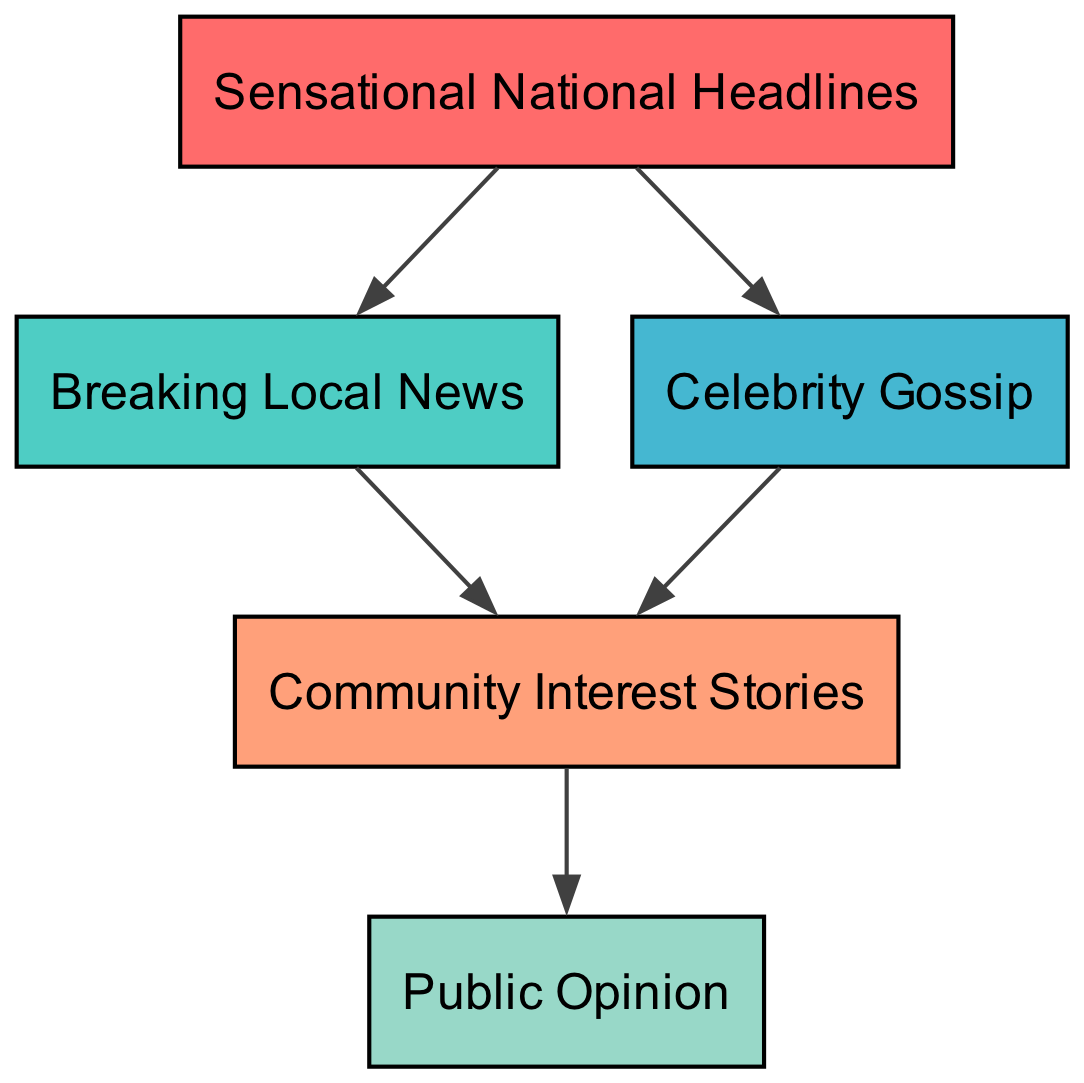What is the top node in the diagram? The top node represents the category with the highest level of influence in the hierarchy, which is "Sensational National Headlines."
Answer: Sensational National Headlines How many nodes are in the diagram? By counting all the unique elements listed in the diagram, there are five nodes: Sensational National Headlines, Breaking Local News, Celebrity Gossip, Community Interest Stories, and Public Opinion.
Answer: 5 What node does "Breaking Local News" prey on? According to the diagram, "Breaking Local News" preys on "Community Interest Stories," indicating that it has a direct influence on that type of story.
Answer: Community Interest Stories Which nodes directly impact "Public Opinion"? The only node that directly impacts "Public Opinion" is "Community Interest Stories," as it is the last in the chain and feeds into public perception.
Answer: Community Interest Stories How many edges are there in total? By analyzing the connections between nodes, we find there are a total of 6 edges: Sensational National Headlines to Breaking Local News, Sensational National Headlines to Celebrity Gossip, Breaking Local News to Community Interest Stories, Celebrity Gossip to Community Interest Stories, and Community Interest Stories to Public Opinion.
Answer: 6 If "Celebrity Gossip" is popular, which other node is affected? If "Celebrity Gossip" is popular, it affects "Community Interest Stories" since it preys on that node, indicating a flow of influence in that direction.
Answer: Community Interest Stories What is the relationship between "Sensational National Headlines" and "Public Opinion"? "Sensational National Headlines" influences "Public Opinion" indirectly through "Breaking Local News" and "Celebrity Gossip," signifying that sensational headlines can shape public perception through local narratives and celebrity stories.
Answer: Indirect Influence What is the lowest level in the diagram? The lowest level in the hierarchy is represented by "Public Opinion," which is the outcome of the influence of all preceding nodes in the food chain.
Answer: Public Opinion Which node is impacted by both "Breaking Local News" and "Celebrity Gossip"? The node that is impacted by both "Breaking Local News" and "Celebrity Gossip" is "Community Interest Stories," as both of them prey on that node.
Answer: Community Interest Stories 